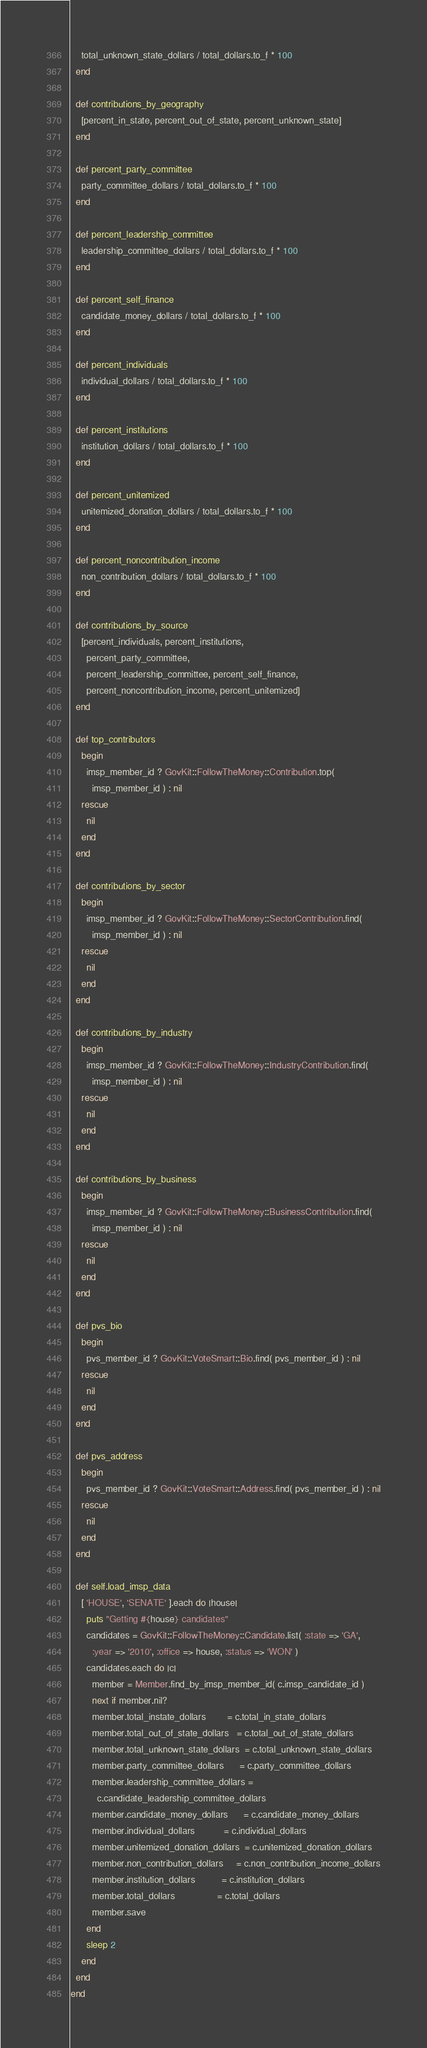Convert code to text. <code><loc_0><loc_0><loc_500><loc_500><_Ruby_>    total_unknown_state_dollars / total_dollars.to_f * 100
  end

  def contributions_by_geography
    [percent_in_state, percent_out_of_state, percent_unknown_state]
  end

  def percent_party_committee
    party_committee_dollars / total_dollars.to_f * 100
  end

  def percent_leadership_committee
    leadership_committee_dollars / total_dollars.to_f * 100
  end

  def percent_self_finance
    candidate_money_dollars / total_dollars.to_f * 100
  end

  def percent_individuals
    individual_dollars / total_dollars.to_f * 100
  end

  def percent_institutions
    institution_dollars / total_dollars.to_f * 100
  end

  def percent_unitemized
    unitemized_donation_dollars / total_dollars.to_f * 100
  end

  def percent_noncontribution_income
    non_contribution_dollars / total_dollars.to_f * 100
  end

  def contributions_by_source
    [percent_individuals, percent_institutions,
      percent_party_committee,
      percent_leadership_committee, percent_self_finance,
      percent_noncontribution_income, percent_unitemized]
  end

  def top_contributors
    begin
      imsp_member_id ? GovKit::FollowTheMoney::Contribution.top(
        imsp_member_id ) : nil
    rescue
      nil
    end
  end

  def contributions_by_sector
    begin
      imsp_member_id ? GovKit::FollowTheMoney::SectorContribution.find(
        imsp_member_id ) : nil
    rescue
      nil
    end
  end

  def contributions_by_industry
    begin
      imsp_member_id ? GovKit::FollowTheMoney::IndustryContribution.find(
        imsp_member_id ) : nil
    rescue
      nil
    end
  end

  def contributions_by_business
    begin
      imsp_member_id ? GovKit::FollowTheMoney::BusinessContribution.find(
        imsp_member_id ) : nil
    rescue
      nil
    end
  end

  def pvs_bio
    begin
      pvs_member_id ? GovKit::VoteSmart::Bio.find( pvs_member_id ) : nil
    rescue
      nil
    end
  end

  def pvs_address
    begin
      pvs_member_id ? GovKit::VoteSmart::Address.find( pvs_member_id ) : nil
    rescue
      nil
    end
  end

  def self.load_imsp_data
    [ 'HOUSE', 'SENATE' ].each do |house|
      puts "Getting #{house} candidates"
      candidates = GovKit::FollowTheMoney::Candidate.list( :state => 'GA',
        :year => '2010', :office => house, :status => 'WON' )
      candidates.each do |c|
        member = Member.find_by_imsp_member_id( c.imsp_candidate_id )
        next if member.nil?
        member.total_instate_dollars        = c.total_in_state_dollars
        member.total_out_of_state_dollars   = c.total_out_of_state_dollars
        member.total_unknown_state_dollars  = c.total_unknown_state_dollars
        member.party_committee_dollars      = c.party_committee_dollars
        member.leadership_committee_dollars =
          c.candidate_leadership_committee_dollars
        member.candidate_money_dollars      = c.candidate_money_dollars
        member.individual_dollars           = c.individual_dollars
        member.unitemized_donation_dollars  = c.unitemized_donation_dollars
        member.non_contribution_dollars     = c.non_contribution_income_dollars
        member.institution_dollars          = c.institution_dollars
        member.total_dollars                = c.total_dollars
        member.save
      end
      sleep 2
    end
  end
end
</code> 